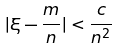Convert formula to latex. <formula><loc_0><loc_0><loc_500><loc_500>| \xi - \frac { m } { n } | < \frac { c } { n ^ { 2 } }</formula> 